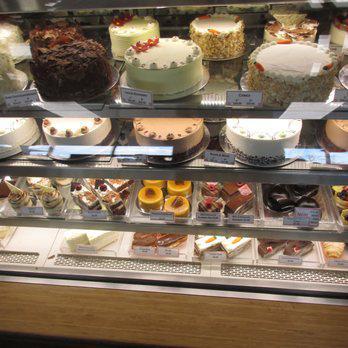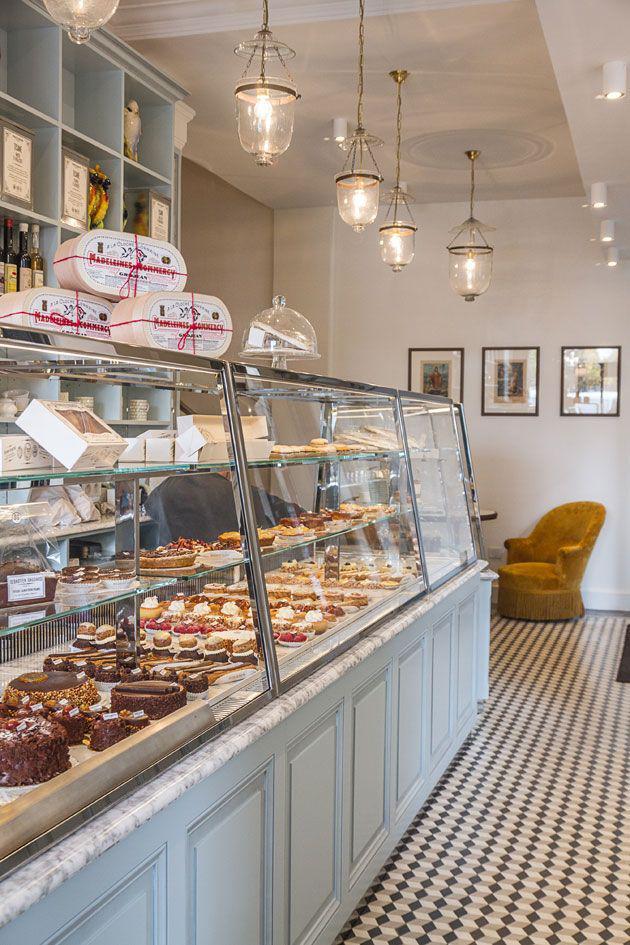The first image is the image on the left, the second image is the image on the right. Assess this claim about the two images: "The floor can be seen in one of the images.". Correct or not? Answer yes or no. Yes. 